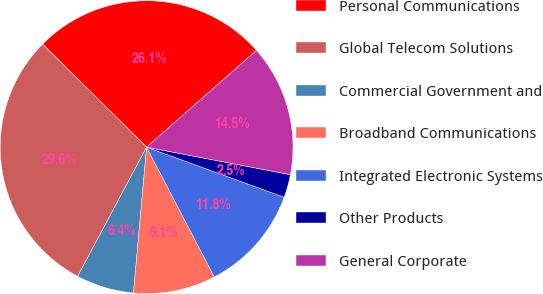Convert chart. <chart><loc_0><loc_0><loc_500><loc_500><pie_chart><fcel>Personal Communications<fcel>Global Telecom Solutions<fcel>Commercial Government and<fcel>Broadband Communications<fcel>Integrated Electronic Systems<fcel>Other Products<fcel>General Corporate<nl><fcel>26.08%<fcel>29.62%<fcel>6.38%<fcel>9.08%<fcel>11.79%<fcel>2.55%<fcel>14.5%<nl></chart> 